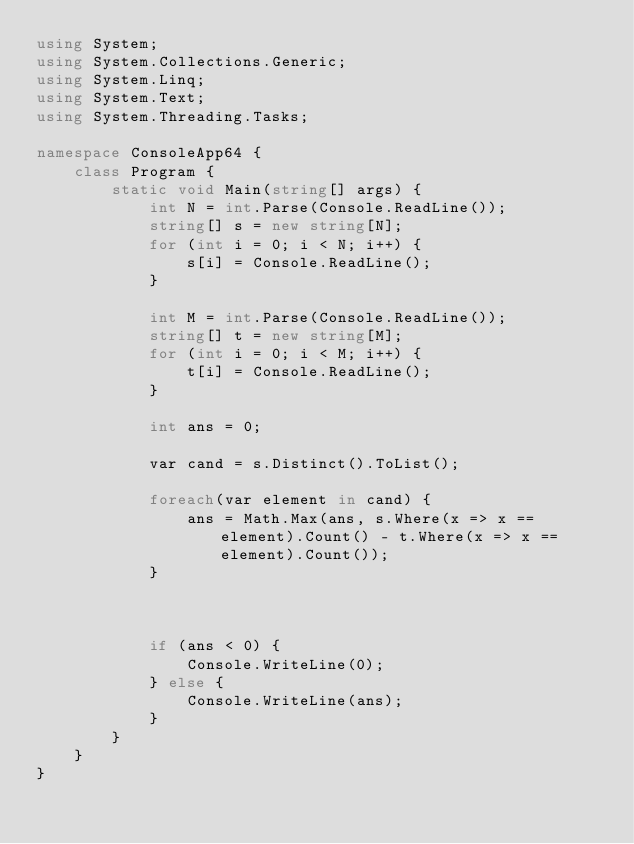Convert code to text. <code><loc_0><loc_0><loc_500><loc_500><_C#_>using System;
using System.Collections.Generic;
using System.Linq;
using System.Text;
using System.Threading.Tasks;

namespace ConsoleApp64 {
    class Program {
        static void Main(string[] args) {
            int N = int.Parse(Console.ReadLine());
            string[] s = new string[N];
            for (int i = 0; i < N; i++) {
                s[i] = Console.ReadLine();
            }

            int M = int.Parse(Console.ReadLine());
            string[] t = new string[M];
            for (int i = 0; i < M; i++) {
                t[i] = Console.ReadLine();
            }

            int ans = 0;

            var cand = s.Distinct().ToList();

            foreach(var element in cand) {
                ans = Math.Max(ans, s.Where(x => x == element).Count() - t.Where(x => x == element).Count());
            }



            if (ans < 0) {
                Console.WriteLine(0);
            } else {
                Console.WriteLine(ans);
            }
        }
    }
}
</code> 